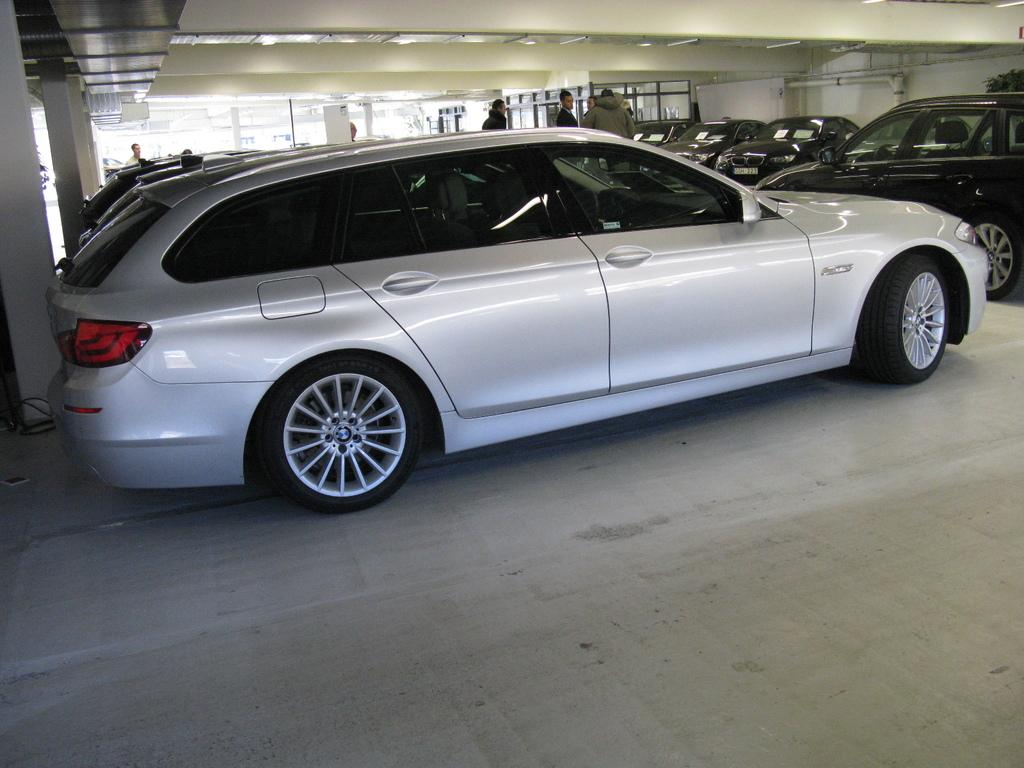What can be seen in the foreground of the image? There are cars and persons in the foreground of the image. Can you describe the location of the scene? The location is in the basement of a building. How many adjustments were made to the knot in the image? There is no knot present in the image. What type of needle can be seen in the image? There is no needle present in the image. 